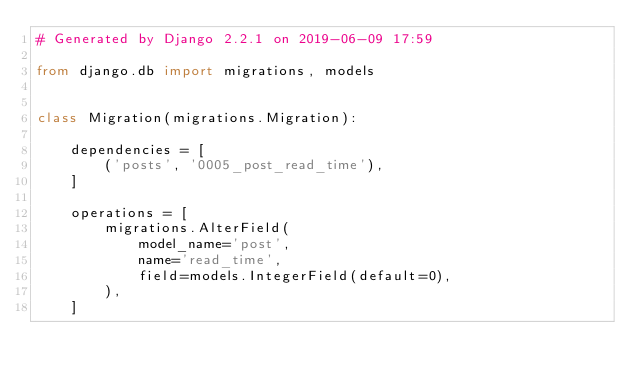<code> <loc_0><loc_0><loc_500><loc_500><_Python_># Generated by Django 2.2.1 on 2019-06-09 17:59

from django.db import migrations, models


class Migration(migrations.Migration):

    dependencies = [
        ('posts', '0005_post_read_time'),
    ]

    operations = [
        migrations.AlterField(
            model_name='post',
            name='read_time',
            field=models.IntegerField(default=0),
        ),
    ]
</code> 